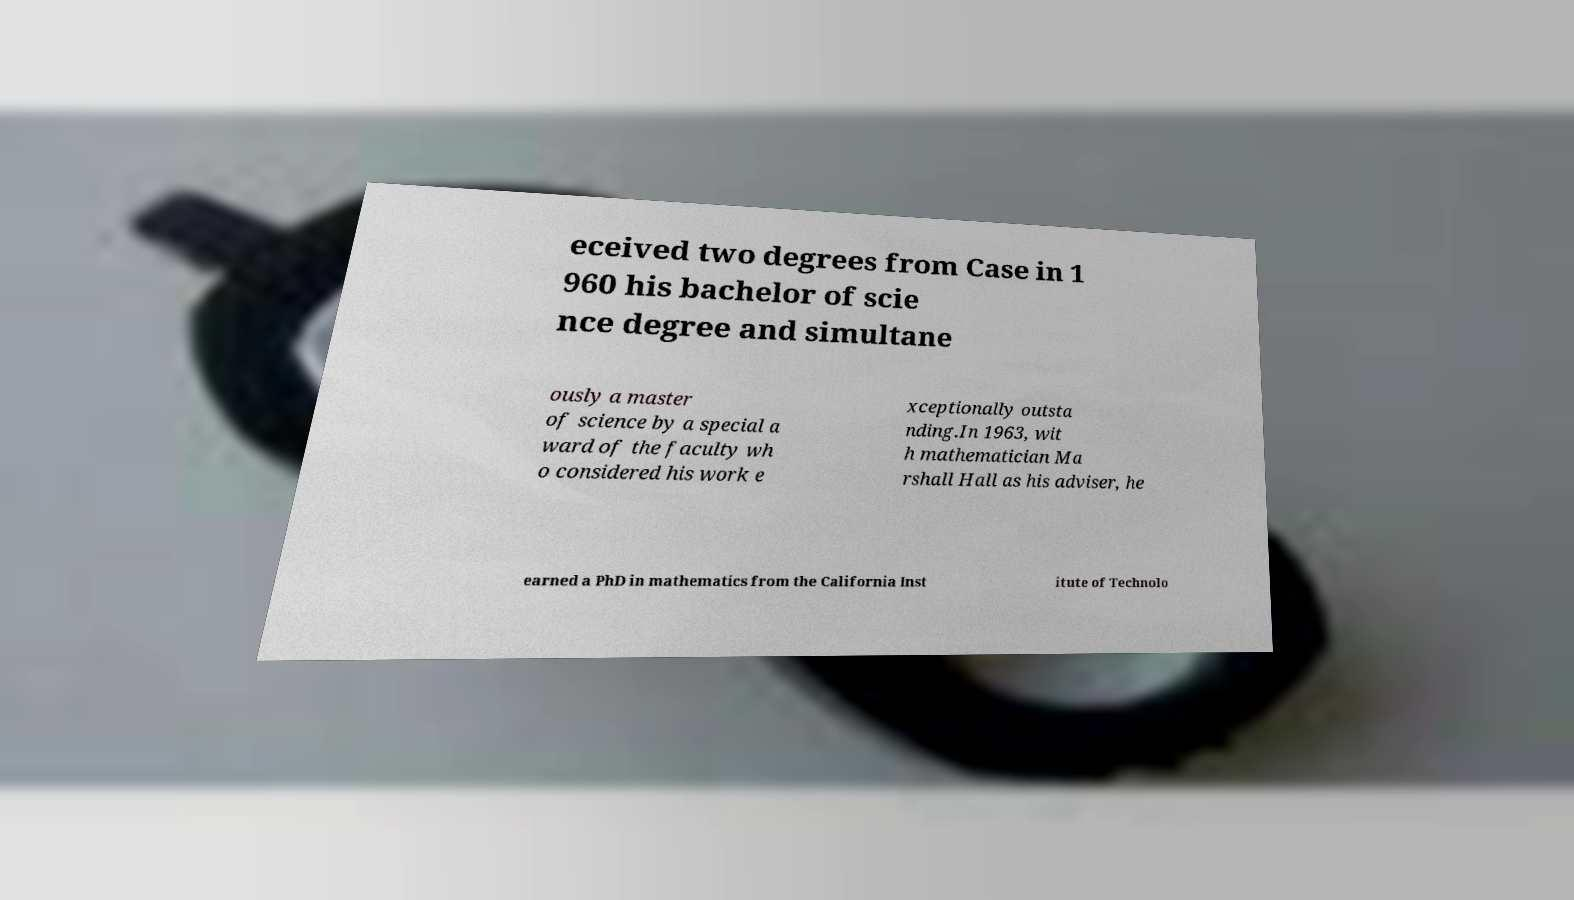Could you assist in decoding the text presented in this image and type it out clearly? eceived two degrees from Case in 1 960 his bachelor of scie nce degree and simultane ously a master of science by a special a ward of the faculty wh o considered his work e xceptionally outsta nding.In 1963, wit h mathematician Ma rshall Hall as his adviser, he earned a PhD in mathematics from the California Inst itute of Technolo 